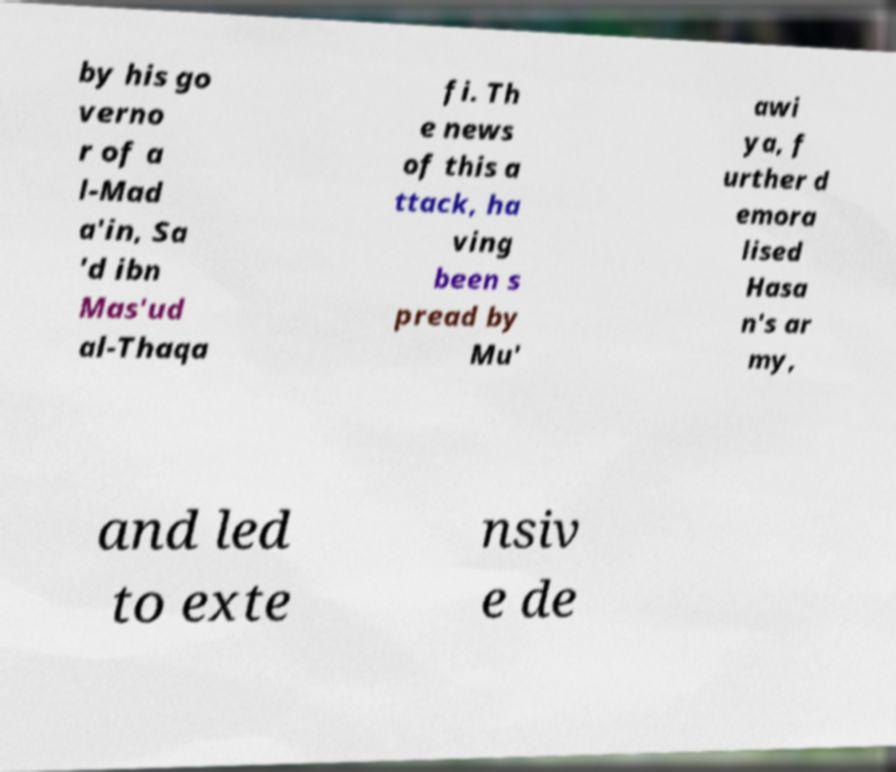There's text embedded in this image that I need extracted. Can you transcribe it verbatim? by his go verno r of a l-Mad a'in, Sa 'd ibn Mas'ud al-Thaqa fi. Th e news of this a ttack, ha ving been s pread by Mu' awi ya, f urther d emora lised Hasa n's ar my, and led to exte nsiv e de 